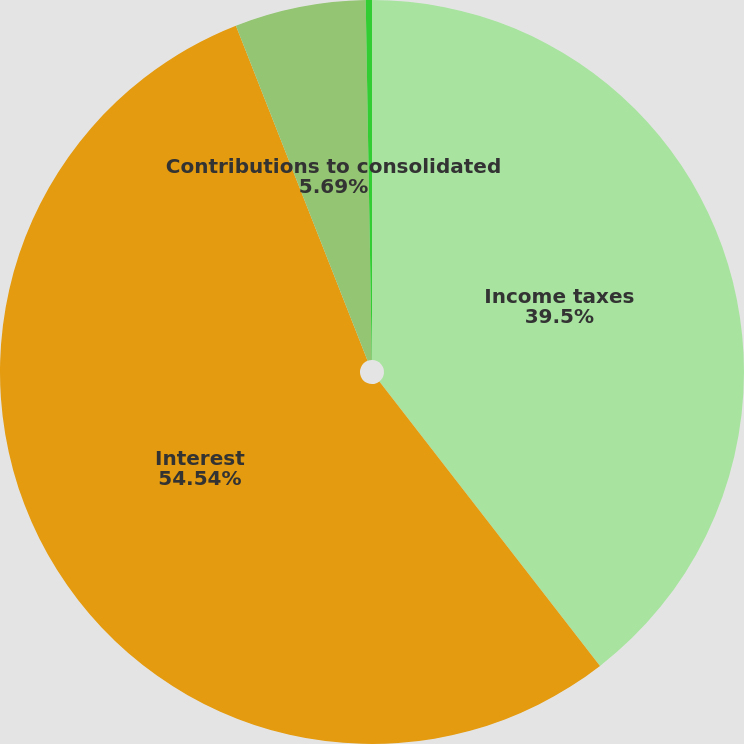Convert chart. <chart><loc_0><loc_0><loc_500><loc_500><pie_chart><fcel>Income taxes<fcel>Interest<fcel>Contributions to consolidated<fcel>Liabilities assumed in<nl><fcel>39.5%<fcel>54.54%<fcel>5.69%<fcel>0.27%<nl></chart> 